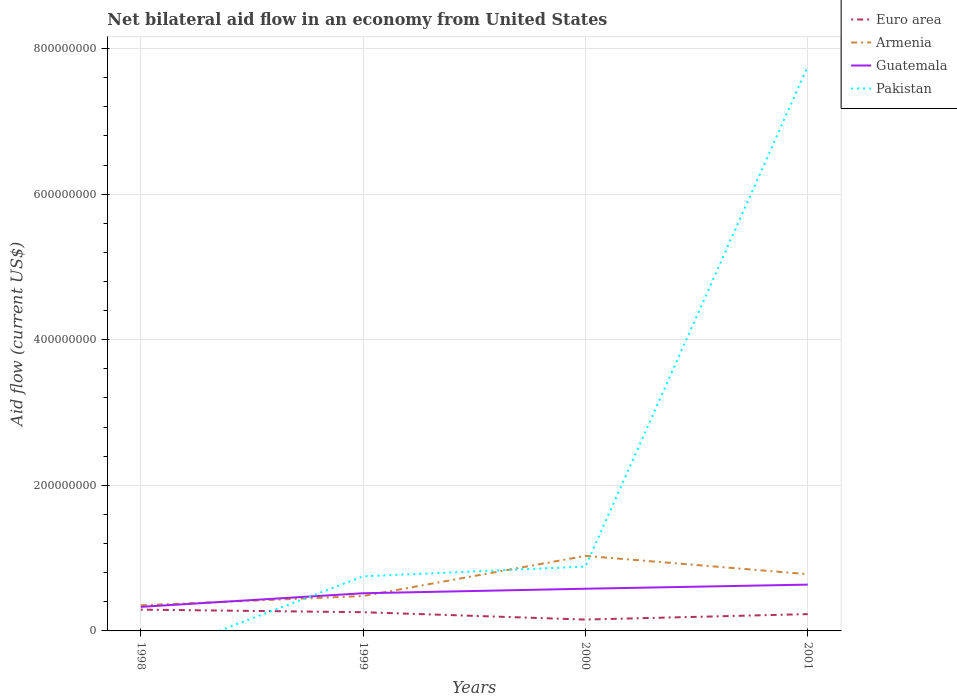How many different coloured lines are there?
Your response must be concise. 4. Does the line corresponding to Guatemala intersect with the line corresponding to Pakistan?
Provide a succinct answer. Yes. What is the total net bilateral aid flow in Euro area in the graph?
Offer a very short reply. -7.48e+06. What is the difference between the highest and the second highest net bilateral aid flow in Guatemala?
Make the answer very short. 3.06e+07. What is the difference between the highest and the lowest net bilateral aid flow in Guatemala?
Provide a short and direct response. 3. Is the net bilateral aid flow in Euro area strictly greater than the net bilateral aid flow in Guatemala over the years?
Ensure brevity in your answer.  Yes. How many lines are there?
Ensure brevity in your answer.  4. How many years are there in the graph?
Keep it short and to the point. 4. What is the difference between two consecutive major ticks on the Y-axis?
Keep it short and to the point. 2.00e+08. Are the values on the major ticks of Y-axis written in scientific E-notation?
Provide a succinct answer. No. How are the legend labels stacked?
Provide a short and direct response. Vertical. What is the title of the graph?
Give a very brief answer. Net bilateral aid flow in an economy from United States. Does "Faeroe Islands" appear as one of the legend labels in the graph?
Your answer should be compact. No. What is the label or title of the X-axis?
Make the answer very short. Years. What is the label or title of the Y-axis?
Provide a short and direct response. Aid flow (current US$). What is the Aid flow (current US$) in Euro area in 1998?
Make the answer very short. 2.92e+07. What is the Aid flow (current US$) in Armenia in 1998?
Your response must be concise. 3.52e+07. What is the Aid flow (current US$) of Guatemala in 1998?
Make the answer very short. 3.30e+07. What is the Aid flow (current US$) in Pakistan in 1998?
Make the answer very short. 0. What is the Aid flow (current US$) of Euro area in 1999?
Provide a short and direct response. 2.57e+07. What is the Aid flow (current US$) in Armenia in 1999?
Ensure brevity in your answer.  4.79e+07. What is the Aid flow (current US$) of Guatemala in 1999?
Your answer should be very brief. 5.18e+07. What is the Aid flow (current US$) in Pakistan in 1999?
Make the answer very short. 7.50e+07. What is the Aid flow (current US$) in Euro area in 2000?
Ensure brevity in your answer.  1.56e+07. What is the Aid flow (current US$) in Armenia in 2000?
Offer a very short reply. 1.03e+08. What is the Aid flow (current US$) in Guatemala in 2000?
Provide a succinct answer. 5.80e+07. What is the Aid flow (current US$) in Pakistan in 2000?
Offer a terse response. 8.85e+07. What is the Aid flow (current US$) in Euro area in 2001?
Provide a short and direct response. 2.31e+07. What is the Aid flow (current US$) of Armenia in 2001?
Provide a short and direct response. 7.80e+07. What is the Aid flow (current US$) of Guatemala in 2001?
Your answer should be very brief. 6.36e+07. What is the Aid flow (current US$) in Pakistan in 2001?
Keep it short and to the point. 7.76e+08. Across all years, what is the maximum Aid flow (current US$) of Euro area?
Your answer should be very brief. 2.92e+07. Across all years, what is the maximum Aid flow (current US$) in Armenia?
Keep it short and to the point. 1.03e+08. Across all years, what is the maximum Aid flow (current US$) in Guatemala?
Give a very brief answer. 6.36e+07. Across all years, what is the maximum Aid flow (current US$) of Pakistan?
Make the answer very short. 7.76e+08. Across all years, what is the minimum Aid flow (current US$) in Euro area?
Provide a short and direct response. 1.56e+07. Across all years, what is the minimum Aid flow (current US$) in Armenia?
Offer a very short reply. 3.52e+07. Across all years, what is the minimum Aid flow (current US$) in Guatemala?
Your answer should be very brief. 3.30e+07. What is the total Aid flow (current US$) of Euro area in the graph?
Offer a terse response. 9.36e+07. What is the total Aid flow (current US$) of Armenia in the graph?
Make the answer very short. 2.64e+08. What is the total Aid flow (current US$) of Guatemala in the graph?
Offer a very short reply. 2.06e+08. What is the total Aid flow (current US$) of Pakistan in the graph?
Offer a very short reply. 9.39e+08. What is the difference between the Aid flow (current US$) in Euro area in 1998 and that in 1999?
Offer a terse response. 3.52e+06. What is the difference between the Aid flow (current US$) of Armenia in 1998 and that in 1999?
Provide a succinct answer. -1.27e+07. What is the difference between the Aid flow (current US$) in Guatemala in 1998 and that in 1999?
Offer a very short reply. -1.87e+07. What is the difference between the Aid flow (current US$) in Euro area in 1998 and that in 2000?
Your answer should be compact. 1.36e+07. What is the difference between the Aid flow (current US$) of Armenia in 1998 and that in 2000?
Your answer should be compact. -6.79e+07. What is the difference between the Aid flow (current US$) of Guatemala in 1998 and that in 2000?
Offer a very short reply. -2.49e+07. What is the difference between the Aid flow (current US$) of Euro area in 1998 and that in 2001?
Ensure brevity in your answer.  6.16e+06. What is the difference between the Aid flow (current US$) of Armenia in 1998 and that in 2001?
Offer a terse response. -4.28e+07. What is the difference between the Aid flow (current US$) of Guatemala in 1998 and that in 2001?
Your response must be concise. -3.06e+07. What is the difference between the Aid flow (current US$) in Euro area in 1999 and that in 2000?
Your response must be concise. 1.01e+07. What is the difference between the Aid flow (current US$) in Armenia in 1999 and that in 2000?
Keep it short and to the point. -5.52e+07. What is the difference between the Aid flow (current US$) of Guatemala in 1999 and that in 2000?
Keep it short and to the point. -6.21e+06. What is the difference between the Aid flow (current US$) in Pakistan in 1999 and that in 2000?
Make the answer very short. -1.35e+07. What is the difference between the Aid flow (current US$) of Euro area in 1999 and that in 2001?
Provide a short and direct response. 2.64e+06. What is the difference between the Aid flow (current US$) in Armenia in 1999 and that in 2001?
Provide a succinct answer. -3.00e+07. What is the difference between the Aid flow (current US$) of Guatemala in 1999 and that in 2001?
Provide a succinct answer. -1.18e+07. What is the difference between the Aid flow (current US$) of Pakistan in 1999 and that in 2001?
Offer a very short reply. -7.01e+08. What is the difference between the Aid flow (current US$) in Euro area in 2000 and that in 2001?
Provide a succinct answer. -7.48e+06. What is the difference between the Aid flow (current US$) in Armenia in 2000 and that in 2001?
Provide a short and direct response. 2.51e+07. What is the difference between the Aid flow (current US$) in Guatemala in 2000 and that in 2001?
Ensure brevity in your answer.  -5.64e+06. What is the difference between the Aid flow (current US$) of Pakistan in 2000 and that in 2001?
Offer a terse response. -6.87e+08. What is the difference between the Aid flow (current US$) of Euro area in 1998 and the Aid flow (current US$) of Armenia in 1999?
Offer a very short reply. -1.87e+07. What is the difference between the Aid flow (current US$) in Euro area in 1998 and the Aid flow (current US$) in Guatemala in 1999?
Give a very brief answer. -2.25e+07. What is the difference between the Aid flow (current US$) of Euro area in 1998 and the Aid flow (current US$) of Pakistan in 1999?
Your answer should be compact. -4.57e+07. What is the difference between the Aid flow (current US$) in Armenia in 1998 and the Aid flow (current US$) in Guatemala in 1999?
Your response must be concise. -1.66e+07. What is the difference between the Aid flow (current US$) in Armenia in 1998 and the Aid flow (current US$) in Pakistan in 1999?
Make the answer very short. -3.98e+07. What is the difference between the Aid flow (current US$) of Guatemala in 1998 and the Aid flow (current US$) of Pakistan in 1999?
Ensure brevity in your answer.  -4.19e+07. What is the difference between the Aid flow (current US$) in Euro area in 1998 and the Aid flow (current US$) in Armenia in 2000?
Provide a succinct answer. -7.38e+07. What is the difference between the Aid flow (current US$) of Euro area in 1998 and the Aid flow (current US$) of Guatemala in 2000?
Ensure brevity in your answer.  -2.87e+07. What is the difference between the Aid flow (current US$) in Euro area in 1998 and the Aid flow (current US$) in Pakistan in 2000?
Your answer should be very brief. -5.92e+07. What is the difference between the Aid flow (current US$) of Armenia in 1998 and the Aid flow (current US$) of Guatemala in 2000?
Ensure brevity in your answer.  -2.28e+07. What is the difference between the Aid flow (current US$) in Armenia in 1998 and the Aid flow (current US$) in Pakistan in 2000?
Provide a short and direct response. -5.33e+07. What is the difference between the Aid flow (current US$) in Guatemala in 1998 and the Aid flow (current US$) in Pakistan in 2000?
Your answer should be compact. -5.54e+07. What is the difference between the Aid flow (current US$) of Euro area in 1998 and the Aid flow (current US$) of Armenia in 2001?
Offer a very short reply. -4.87e+07. What is the difference between the Aid flow (current US$) of Euro area in 1998 and the Aid flow (current US$) of Guatemala in 2001?
Provide a short and direct response. -3.44e+07. What is the difference between the Aid flow (current US$) in Euro area in 1998 and the Aid flow (current US$) in Pakistan in 2001?
Ensure brevity in your answer.  -7.46e+08. What is the difference between the Aid flow (current US$) in Armenia in 1998 and the Aid flow (current US$) in Guatemala in 2001?
Provide a succinct answer. -2.84e+07. What is the difference between the Aid flow (current US$) in Armenia in 1998 and the Aid flow (current US$) in Pakistan in 2001?
Make the answer very short. -7.40e+08. What is the difference between the Aid flow (current US$) in Guatemala in 1998 and the Aid flow (current US$) in Pakistan in 2001?
Your answer should be very brief. -7.43e+08. What is the difference between the Aid flow (current US$) of Euro area in 1999 and the Aid flow (current US$) of Armenia in 2000?
Your answer should be compact. -7.73e+07. What is the difference between the Aid flow (current US$) in Euro area in 1999 and the Aid flow (current US$) in Guatemala in 2000?
Ensure brevity in your answer.  -3.22e+07. What is the difference between the Aid flow (current US$) of Euro area in 1999 and the Aid flow (current US$) of Pakistan in 2000?
Provide a succinct answer. -6.27e+07. What is the difference between the Aid flow (current US$) in Armenia in 1999 and the Aid flow (current US$) in Guatemala in 2000?
Provide a short and direct response. -1.01e+07. What is the difference between the Aid flow (current US$) of Armenia in 1999 and the Aid flow (current US$) of Pakistan in 2000?
Ensure brevity in your answer.  -4.06e+07. What is the difference between the Aid flow (current US$) of Guatemala in 1999 and the Aid flow (current US$) of Pakistan in 2000?
Give a very brief answer. -3.67e+07. What is the difference between the Aid flow (current US$) in Euro area in 1999 and the Aid flow (current US$) in Armenia in 2001?
Your answer should be very brief. -5.22e+07. What is the difference between the Aid flow (current US$) of Euro area in 1999 and the Aid flow (current US$) of Guatemala in 2001?
Provide a succinct answer. -3.79e+07. What is the difference between the Aid flow (current US$) of Euro area in 1999 and the Aid flow (current US$) of Pakistan in 2001?
Ensure brevity in your answer.  -7.50e+08. What is the difference between the Aid flow (current US$) of Armenia in 1999 and the Aid flow (current US$) of Guatemala in 2001?
Ensure brevity in your answer.  -1.57e+07. What is the difference between the Aid flow (current US$) of Armenia in 1999 and the Aid flow (current US$) of Pakistan in 2001?
Your answer should be compact. -7.28e+08. What is the difference between the Aid flow (current US$) in Guatemala in 1999 and the Aid flow (current US$) in Pakistan in 2001?
Offer a terse response. -7.24e+08. What is the difference between the Aid flow (current US$) of Euro area in 2000 and the Aid flow (current US$) of Armenia in 2001?
Make the answer very short. -6.24e+07. What is the difference between the Aid flow (current US$) in Euro area in 2000 and the Aid flow (current US$) in Guatemala in 2001?
Offer a terse response. -4.80e+07. What is the difference between the Aid flow (current US$) of Euro area in 2000 and the Aid flow (current US$) of Pakistan in 2001?
Keep it short and to the point. -7.60e+08. What is the difference between the Aid flow (current US$) in Armenia in 2000 and the Aid flow (current US$) in Guatemala in 2001?
Provide a succinct answer. 3.95e+07. What is the difference between the Aid flow (current US$) in Armenia in 2000 and the Aid flow (current US$) in Pakistan in 2001?
Make the answer very short. -6.73e+08. What is the difference between the Aid flow (current US$) of Guatemala in 2000 and the Aid flow (current US$) of Pakistan in 2001?
Keep it short and to the point. -7.18e+08. What is the average Aid flow (current US$) of Euro area per year?
Ensure brevity in your answer.  2.34e+07. What is the average Aid flow (current US$) of Armenia per year?
Make the answer very short. 6.60e+07. What is the average Aid flow (current US$) of Guatemala per year?
Give a very brief answer. 5.16e+07. What is the average Aid flow (current US$) in Pakistan per year?
Ensure brevity in your answer.  2.35e+08. In the year 1998, what is the difference between the Aid flow (current US$) in Euro area and Aid flow (current US$) in Armenia?
Your answer should be very brief. -5.96e+06. In the year 1998, what is the difference between the Aid flow (current US$) in Euro area and Aid flow (current US$) in Guatemala?
Give a very brief answer. -3.81e+06. In the year 1998, what is the difference between the Aid flow (current US$) in Armenia and Aid flow (current US$) in Guatemala?
Give a very brief answer. 2.15e+06. In the year 1999, what is the difference between the Aid flow (current US$) in Euro area and Aid flow (current US$) in Armenia?
Ensure brevity in your answer.  -2.22e+07. In the year 1999, what is the difference between the Aid flow (current US$) of Euro area and Aid flow (current US$) of Guatemala?
Make the answer very short. -2.60e+07. In the year 1999, what is the difference between the Aid flow (current US$) of Euro area and Aid flow (current US$) of Pakistan?
Offer a very short reply. -4.92e+07. In the year 1999, what is the difference between the Aid flow (current US$) of Armenia and Aid flow (current US$) of Guatemala?
Your answer should be compact. -3.85e+06. In the year 1999, what is the difference between the Aid flow (current US$) of Armenia and Aid flow (current US$) of Pakistan?
Keep it short and to the point. -2.71e+07. In the year 1999, what is the difference between the Aid flow (current US$) in Guatemala and Aid flow (current US$) in Pakistan?
Offer a very short reply. -2.32e+07. In the year 2000, what is the difference between the Aid flow (current US$) in Euro area and Aid flow (current US$) in Armenia?
Offer a very short reply. -8.75e+07. In the year 2000, what is the difference between the Aid flow (current US$) of Euro area and Aid flow (current US$) of Guatemala?
Your response must be concise. -4.24e+07. In the year 2000, what is the difference between the Aid flow (current US$) of Euro area and Aid flow (current US$) of Pakistan?
Your response must be concise. -7.29e+07. In the year 2000, what is the difference between the Aid flow (current US$) in Armenia and Aid flow (current US$) in Guatemala?
Ensure brevity in your answer.  4.51e+07. In the year 2000, what is the difference between the Aid flow (current US$) of Armenia and Aid flow (current US$) of Pakistan?
Offer a terse response. 1.46e+07. In the year 2000, what is the difference between the Aid flow (current US$) of Guatemala and Aid flow (current US$) of Pakistan?
Ensure brevity in your answer.  -3.05e+07. In the year 2001, what is the difference between the Aid flow (current US$) in Euro area and Aid flow (current US$) in Armenia?
Your answer should be compact. -5.49e+07. In the year 2001, what is the difference between the Aid flow (current US$) of Euro area and Aid flow (current US$) of Guatemala?
Keep it short and to the point. -4.05e+07. In the year 2001, what is the difference between the Aid flow (current US$) in Euro area and Aid flow (current US$) in Pakistan?
Provide a short and direct response. -7.53e+08. In the year 2001, what is the difference between the Aid flow (current US$) in Armenia and Aid flow (current US$) in Guatemala?
Make the answer very short. 1.44e+07. In the year 2001, what is the difference between the Aid flow (current US$) of Armenia and Aid flow (current US$) of Pakistan?
Make the answer very short. -6.98e+08. In the year 2001, what is the difference between the Aid flow (current US$) of Guatemala and Aid flow (current US$) of Pakistan?
Ensure brevity in your answer.  -7.12e+08. What is the ratio of the Aid flow (current US$) in Euro area in 1998 to that in 1999?
Provide a short and direct response. 1.14. What is the ratio of the Aid flow (current US$) of Armenia in 1998 to that in 1999?
Provide a succinct answer. 0.73. What is the ratio of the Aid flow (current US$) in Guatemala in 1998 to that in 1999?
Your answer should be compact. 0.64. What is the ratio of the Aid flow (current US$) of Euro area in 1998 to that in 2000?
Your response must be concise. 1.87. What is the ratio of the Aid flow (current US$) of Armenia in 1998 to that in 2000?
Your answer should be very brief. 0.34. What is the ratio of the Aid flow (current US$) in Guatemala in 1998 to that in 2000?
Make the answer very short. 0.57. What is the ratio of the Aid flow (current US$) of Euro area in 1998 to that in 2001?
Your response must be concise. 1.27. What is the ratio of the Aid flow (current US$) of Armenia in 1998 to that in 2001?
Offer a very short reply. 0.45. What is the ratio of the Aid flow (current US$) of Guatemala in 1998 to that in 2001?
Your response must be concise. 0.52. What is the ratio of the Aid flow (current US$) of Euro area in 1999 to that in 2000?
Give a very brief answer. 1.65. What is the ratio of the Aid flow (current US$) of Armenia in 1999 to that in 2000?
Give a very brief answer. 0.46. What is the ratio of the Aid flow (current US$) of Guatemala in 1999 to that in 2000?
Give a very brief answer. 0.89. What is the ratio of the Aid flow (current US$) of Pakistan in 1999 to that in 2000?
Provide a short and direct response. 0.85. What is the ratio of the Aid flow (current US$) of Euro area in 1999 to that in 2001?
Give a very brief answer. 1.11. What is the ratio of the Aid flow (current US$) in Armenia in 1999 to that in 2001?
Your response must be concise. 0.61. What is the ratio of the Aid flow (current US$) in Guatemala in 1999 to that in 2001?
Offer a very short reply. 0.81. What is the ratio of the Aid flow (current US$) of Pakistan in 1999 to that in 2001?
Give a very brief answer. 0.1. What is the ratio of the Aid flow (current US$) in Euro area in 2000 to that in 2001?
Offer a terse response. 0.68. What is the ratio of the Aid flow (current US$) of Armenia in 2000 to that in 2001?
Your answer should be compact. 1.32. What is the ratio of the Aid flow (current US$) in Guatemala in 2000 to that in 2001?
Your response must be concise. 0.91. What is the ratio of the Aid flow (current US$) in Pakistan in 2000 to that in 2001?
Provide a succinct answer. 0.11. What is the difference between the highest and the second highest Aid flow (current US$) in Euro area?
Give a very brief answer. 3.52e+06. What is the difference between the highest and the second highest Aid flow (current US$) of Armenia?
Your answer should be compact. 2.51e+07. What is the difference between the highest and the second highest Aid flow (current US$) in Guatemala?
Your answer should be very brief. 5.64e+06. What is the difference between the highest and the second highest Aid flow (current US$) of Pakistan?
Provide a succinct answer. 6.87e+08. What is the difference between the highest and the lowest Aid flow (current US$) in Euro area?
Make the answer very short. 1.36e+07. What is the difference between the highest and the lowest Aid flow (current US$) in Armenia?
Ensure brevity in your answer.  6.79e+07. What is the difference between the highest and the lowest Aid flow (current US$) of Guatemala?
Make the answer very short. 3.06e+07. What is the difference between the highest and the lowest Aid flow (current US$) in Pakistan?
Give a very brief answer. 7.76e+08. 